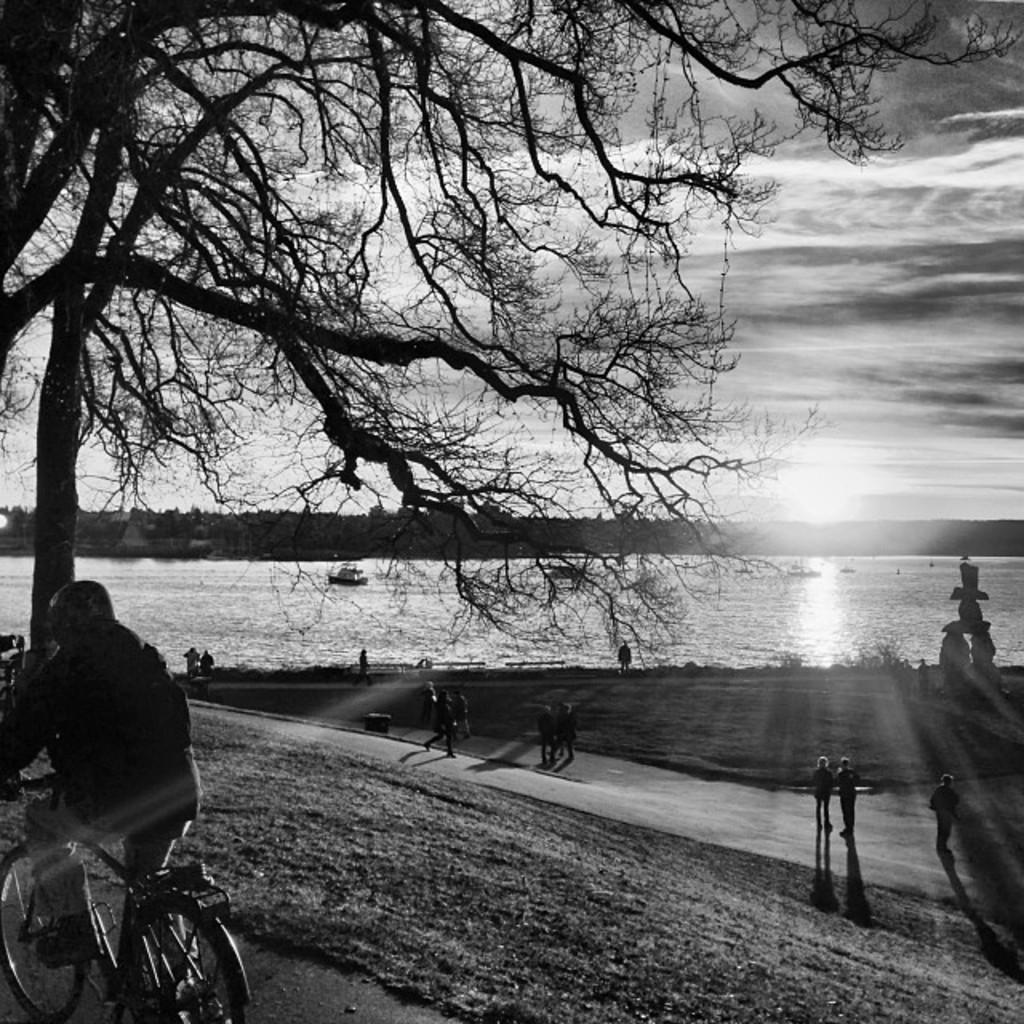What type of body of water is present in the image? There is a lake in the image. What object can be seen floating in the lake? There is a tray in the lake. What activity is the man in the image engaged in? The man is riding a bicycle in the image. What are the people in the image doing? There are people standing in front of the lake. What type of rice is being cooked in the image? There is no rice present in the image; it features a lake, a tray, a man riding a bicycle, and people standing in front of the lake. 